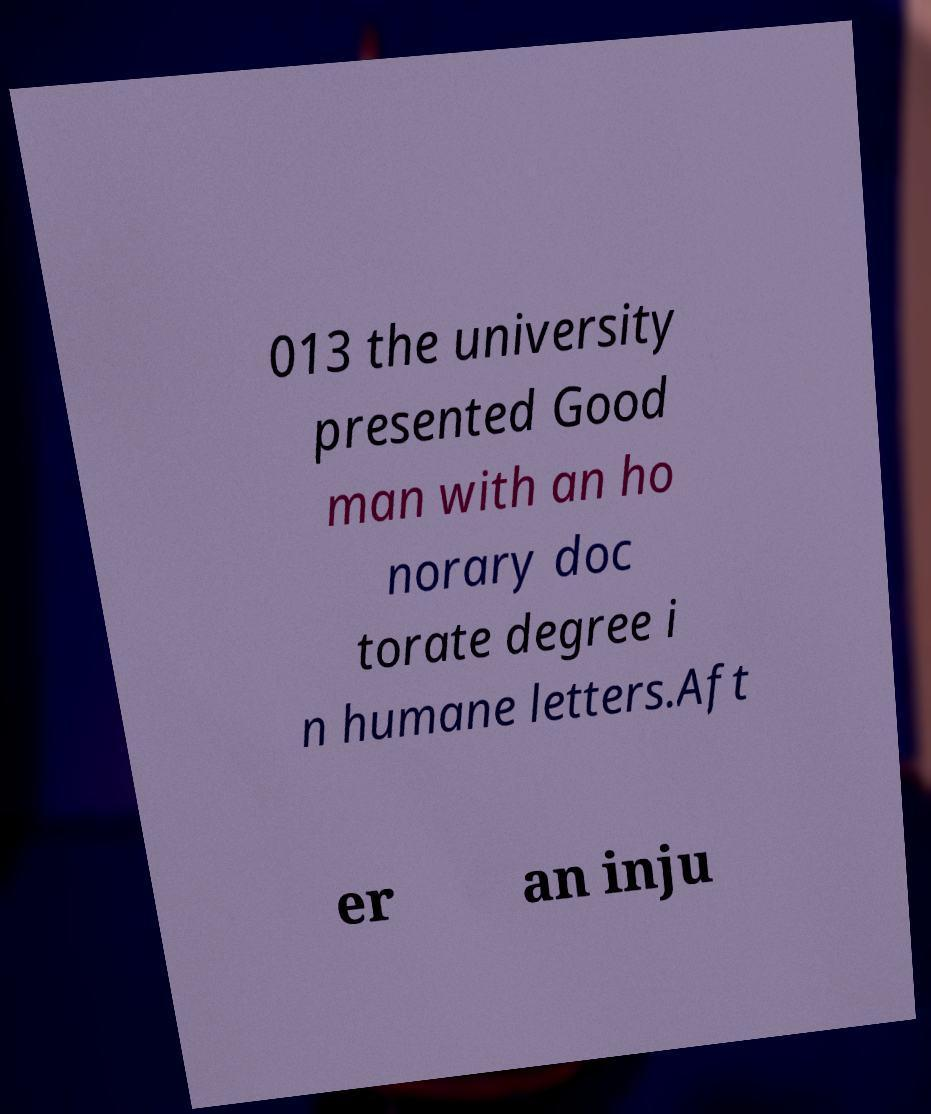I need the written content from this picture converted into text. Can you do that? 013 the university presented Good man with an ho norary doc torate degree i n humane letters.Aft er an inju 